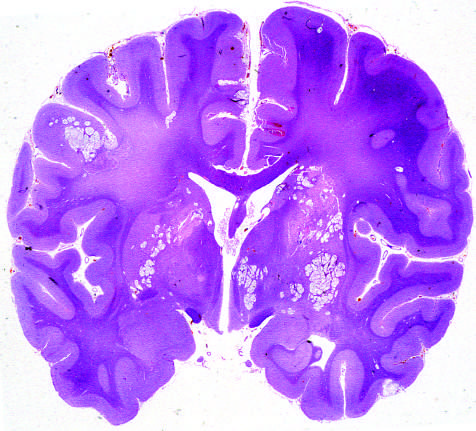s the whole-brain section showing the numerous areas of tissue destruction associated with the spread of organisms in the perivascular spaces?
Answer the question using a single word or phrase. Yes 